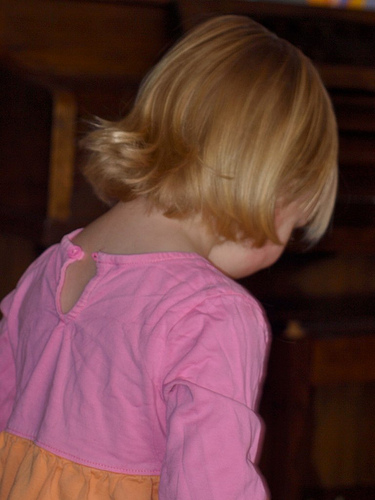<image>
Is the shirt under the head? Yes. The shirt is positioned underneath the head, with the head above it in the vertical space. 